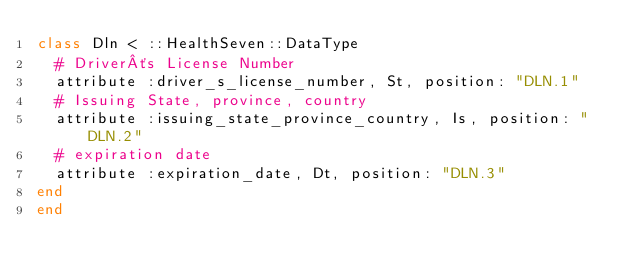Convert code to text. <code><loc_0><loc_0><loc_500><loc_500><_Ruby_>class Dln < ::HealthSeven::DataType
  # Driver´s License Number
  attribute :driver_s_license_number, St, position: "DLN.1"
  # Issuing State, province, country
  attribute :issuing_state_province_country, Is, position: "DLN.2"
  # expiration date
  attribute :expiration_date, Dt, position: "DLN.3"
end
end</code> 